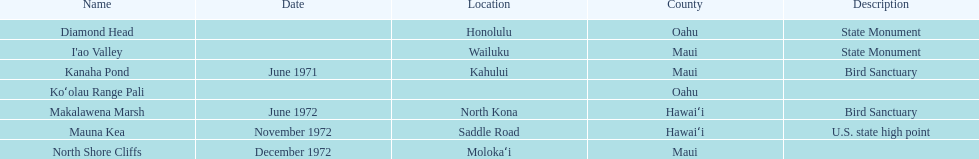What is the overall count of landmarks situated in maui? 3. Would you mind parsing the complete table? {'header': ['Name', 'Date', 'Location', 'County', 'Description'], 'rows': [['Diamond Head', '', 'Honolulu', 'Oahu', 'State Monument'], ["I'ao Valley", '', 'Wailuku', 'Maui', 'State Monument'], ['Kanaha Pond', 'June 1971', 'Kahului', 'Maui', 'Bird Sanctuary'], ['Koʻolau Range Pali', '', '', 'Oahu', ''], ['Makalawena Marsh', 'June 1972', 'North Kona', 'Hawaiʻi', 'Bird Sanctuary'], ['Mauna Kea', 'November 1972', 'Saddle Road', 'Hawaiʻi', 'U.S. state high point'], ['North Shore Cliffs', 'December 1972', 'Molokaʻi', 'Maui', '']]} 